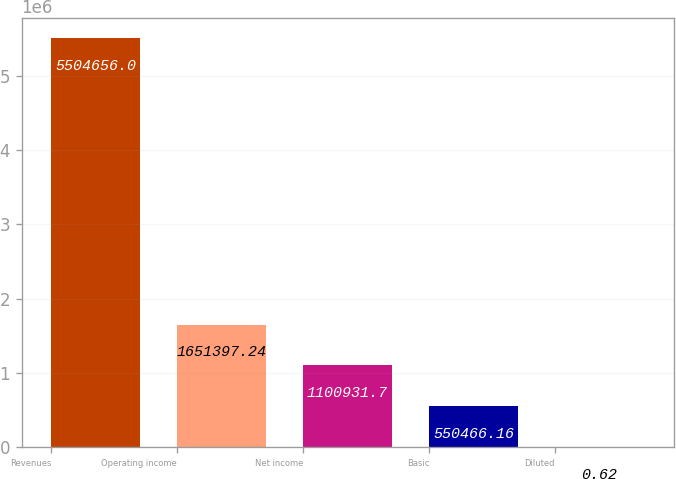<chart> <loc_0><loc_0><loc_500><loc_500><bar_chart><fcel>Revenues<fcel>Operating income<fcel>Net income<fcel>Basic<fcel>Diluted<nl><fcel>5.50466e+06<fcel>1.6514e+06<fcel>1.10093e+06<fcel>550466<fcel>0.62<nl></chart> 